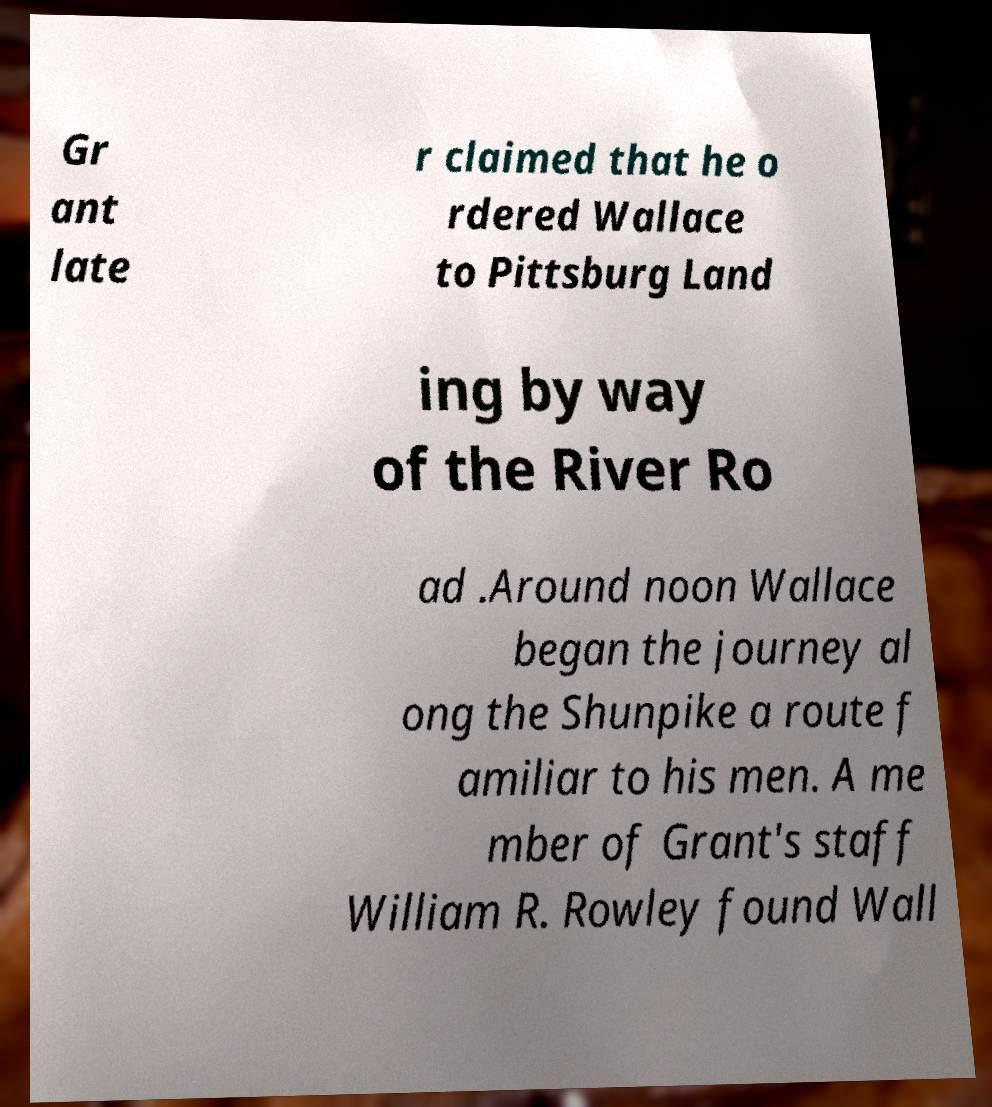Can you accurately transcribe the text from the provided image for me? Gr ant late r claimed that he o rdered Wallace to Pittsburg Land ing by way of the River Ro ad .Around noon Wallace began the journey al ong the Shunpike a route f amiliar to his men. A me mber of Grant's staff William R. Rowley found Wall 